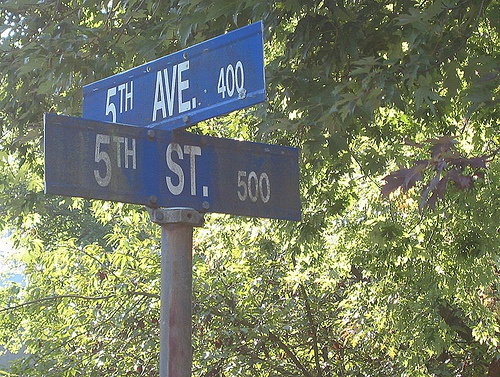Describe the objects in this image and their specific colors. I can see various objects in this image with different colors. 